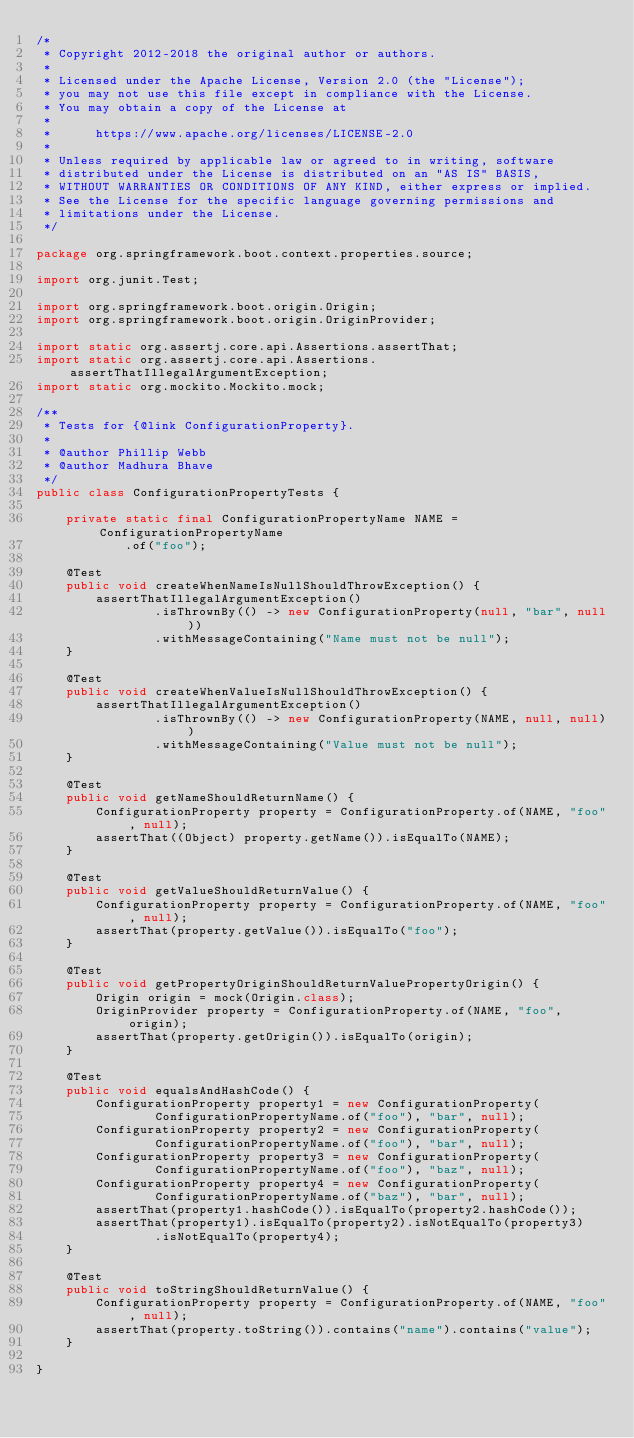<code> <loc_0><loc_0><loc_500><loc_500><_Java_>/*
 * Copyright 2012-2018 the original author or authors.
 *
 * Licensed under the Apache License, Version 2.0 (the "License");
 * you may not use this file except in compliance with the License.
 * You may obtain a copy of the License at
 *
 *      https://www.apache.org/licenses/LICENSE-2.0
 *
 * Unless required by applicable law or agreed to in writing, software
 * distributed under the License is distributed on an "AS IS" BASIS,
 * WITHOUT WARRANTIES OR CONDITIONS OF ANY KIND, either express or implied.
 * See the License for the specific language governing permissions and
 * limitations under the License.
 */

package org.springframework.boot.context.properties.source;

import org.junit.Test;

import org.springframework.boot.origin.Origin;
import org.springframework.boot.origin.OriginProvider;

import static org.assertj.core.api.Assertions.assertThat;
import static org.assertj.core.api.Assertions.assertThatIllegalArgumentException;
import static org.mockito.Mockito.mock;

/**
 * Tests for {@link ConfigurationProperty}.
 *
 * @author Phillip Webb
 * @author Madhura Bhave
 */
public class ConfigurationPropertyTests {

	private static final ConfigurationPropertyName NAME = ConfigurationPropertyName
			.of("foo");

	@Test
	public void createWhenNameIsNullShouldThrowException() {
		assertThatIllegalArgumentException()
				.isThrownBy(() -> new ConfigurationProperty(null, "bar", null))
				.withMessageContaining("Name must not be null");
	}

	@Test
	public void createWhenValueIsNullShouldThrowException() {
		assertThatIllegalArgumentException()
				.isThrownBy(() -> new ConfigurationProperty(NAME, null, null))
				.withMessageContaining("Value must not be null");
	}

	@Test
	public void getNameShouldReturnName() {
		ConfigurationProperty property = ConfigurationProperty.of(NAME, "foo", null);
		assertThat((Object) property.getName()).isEqualTo(NAME);
	}

	@Test
	public void getValueShouldReturnValue() {
		ConfigurationProperty property = ConfigurationProperty.of(NAME, "foo", null);
		assertThat(property.getValue()).isEqualTo("foo");
	}

	@Test
	public void getPropertyOriginShouldReturnValuePropertyOrigin() {
		Origin origin = mock(Origin.class);
		OriginProvider property = ConfigurationProperty.of(NAME, "foo", origin);
		assertThat(property.getOrigin()).isEqualTo(origin);
	}

	@Test
	public void equalsAndHashCode() {
		ConfigurationProperty property1 = new ConfigurationProperty(
				ConfigurationPropertyName.of("foo"), "bar", null);
		ConfigurationProperty property2 = new ConfigurationProperty(
				ConfigurationPropertyName.of("foo"), "bar", null);
		ConfigurationProperty property3 = new ConfigurationProperty(
				ConfigurationPropertyName.of("foo"), "baz", null);
		ConfigurationProperty property4 = new ConfigurationProperty(
				ConfigurationPropertyName.of("baz"), "bar", null);
		assertThat(property1.hashCode()).isEqualTo(property2.hashCode());
		assertThat(property1).isEqualTo(property2).isNotEqualTo(property3)
				.isNotEqualTo(property4);
	}

	@Test
	public void toStringShouldReturnValue() {
		ConfigurationProperty property = ConfigurationProperty.of(NAME, "foo", null);
		assertThat(property.toString()).contains("name").contains("value");
	}

}
</code> 